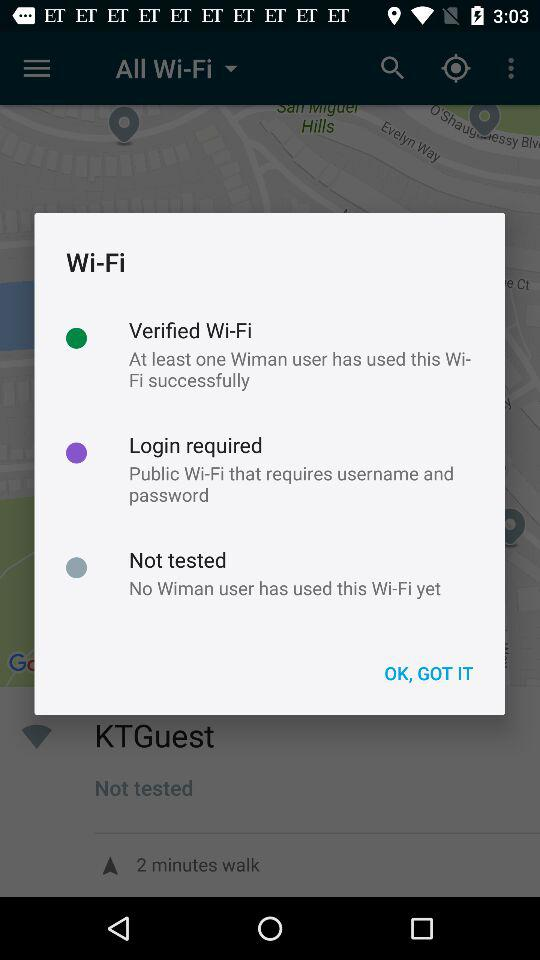How many Wi-Fis have not been tested by Wiman users?
Answer the question using a single word or phrase. 1 